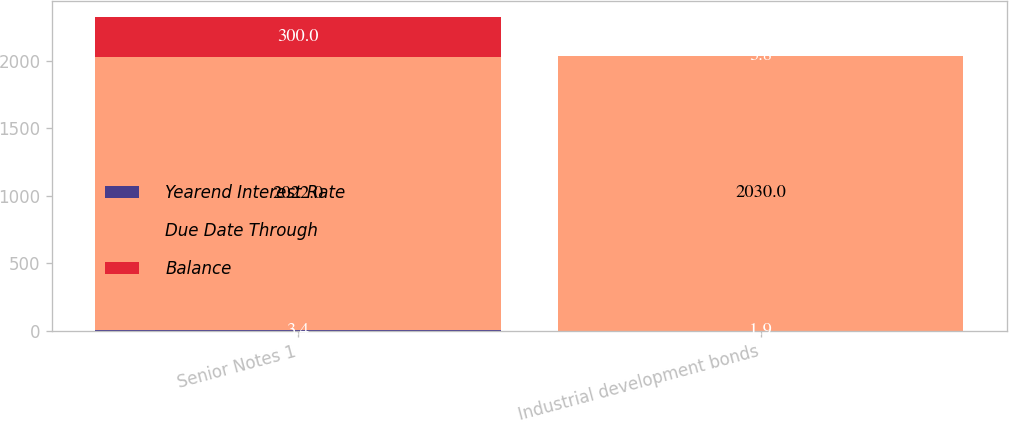Convert chart. <chart><loc_0><loc_0><loc_500><loc_500><stacked_bar_chart><ecel><fcel>Senior Notes 1<fcel>Industrial development bonds<nl><fcel>Yearend Interest Rate<fcel>3.4<fcel>1.9<nl><fcel>Due Date Through<fcel>2022<fcel>2030<nl><fcel>Balance<fcel>300<fcel>3.8<nl></chart> 